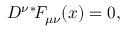<formula> <loc_0><loc_0><loc_500><loc_500>D ^ { \nu ^ { * } \, F _ { \mu \nu } ( x ) = 0 ,</formula> 